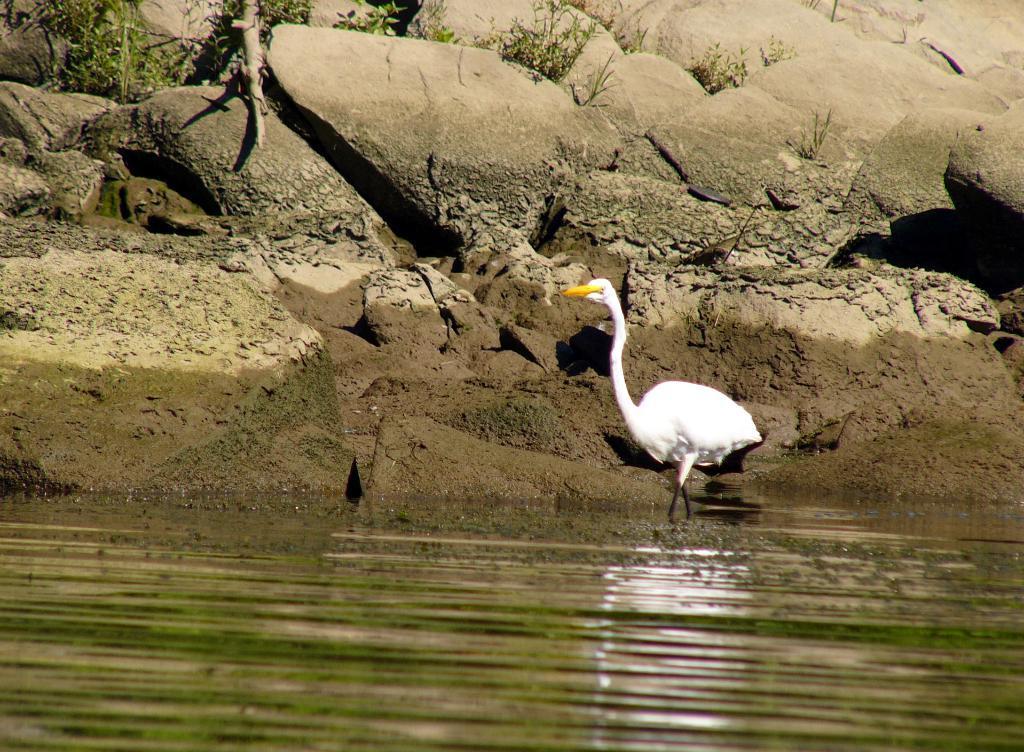How would you summarize this image in a sentence or two? In this image we can see a duck, rocks, plants, also we can see the water, and a wooden stick. 